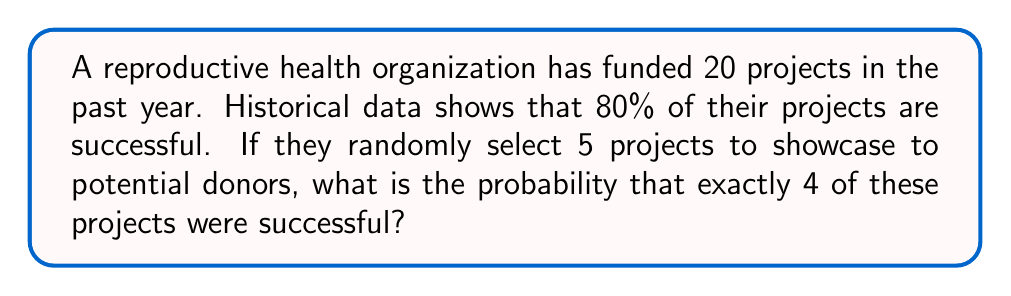Teach me how to tackle this problem. To solve this problem, we'll use the binomial probability formula, as we're dealing with a fixed number of independent trials (selecting 5 projects) with two possible outcomes for each (success or failure).

Let's break it down step-by-step:

1) The binomial probability formula is:

   $$ P(X = k) = \binom{n}{k} p^k (1-p)^{n-k} $$

   Where:
   $n$ = number of trials (5 projects selected)
   $k$ = number of successes (4 successful projects)
   $p$ = probability of success for each trial (80% or 0.8)

2) Let's substitute our values:

   $$ P(X = 4) = \binom{5}{4} (0.8)^4 (1-0.8)^{5-4} $$

3) Simplify:

   $$ P(X = 4) = \binom{5}{4} (0.8)^4 (0.2)^1 $$

4) Calculate the binomial coefficient:

   $$ \binom{5}{4} = \frac{5!}{4!(5-4)!} = \frac{5!}{4!1!} = 5 $$

5) Now our equation looks like:

   $$ P(X = 4) = 5 \cdot (0.8)^4 \cdot (0.2) $$

6) Calculate:

   $$ P(X = 4) = 5 \cdot 0.4096 \cdot 0.2 = 0.4096 $$

Therefore, the probability of selecting exactly 4 successful projects out of 5 is approximately 0.4096 or 40.96%.
Answer: 0.4096 